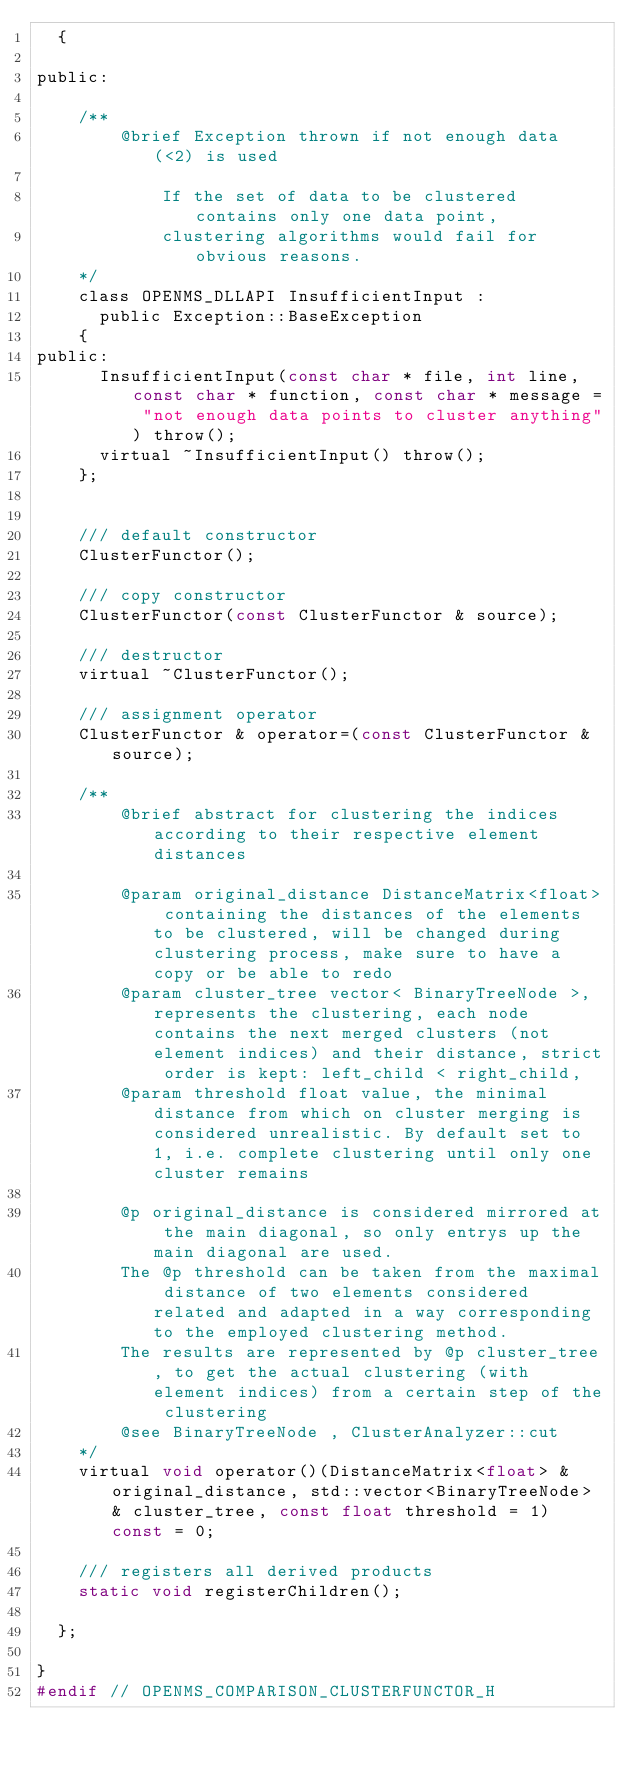<code> <loc_0><loc_0><loc_500><loc_500><_C_>  {

public:

    /**
        @brief Exception thrown if not enough data (<2) is used

            If the set of data to be clustered contains only one data point,
            clustering algorithms would fail for obvious reasons.
    */
    class OPENMS_DLLAPI InsufficientInput :
      public Exception::BaseException
    {
public:
      InsufficientInput(const char * file, int line, const char * function, const char * message = "not enough data points to cluster anything") throw();
      virtual ~InsufficientInput() throw();
    };


    /// default constructor
    ClusterFunctor();

    /// copy constructor
    ClusterFunctor(const ClusterFunctor & source);

    /// destructor
    virtual ~ClusterFunctor();

    /// assignment operator
    ClusterFunctor & operator=(const ClusterFunctor & source);

    /**
        @brief abstract for clustering the indices according to their respective element distances

        @param original_distance DistanceMatrix<float> containing the distances of the elements to be clustered, will be changed during clustering process, make sure to have a copy or be able to redo
        @param cluster_tree vector< BinaryTreeNode >, represents the clustering, each node contains the next merged clusters (not element indices) and their distance, strict order is kept: left_child < right_child,
        @param threshold float value, the minimal distance from which on cluster merging is considered unrealistic. By default set to 1, i.e. complete clustering until only one cluster remains

        @p original_distance is considered mirrored at the main diagonal, so only entrys up the main diagonal are used.
        The @p threshold can be taken from the maximal distance of two elements considered related and adapted in a way corresponding to the employed clustering method.
        The results are represented by @p cluster_tree, to get the actual clustering (with element indices) from a certain step of the clustering
        @see BinaryTreeNode , ClusterAnalyzer::cut
    */
    virtual void operator()(DistanceMatrix<float> & original_distance, std::vector<BinaryTreeNode> & cluster_tree, const float threshold = 1) const = 0;

    /// registers all derived products
    static void registerChildren();

  };

}
#endif // OPENMS_COMPARISON_CLUSTERFUNCTOR_H
</code> 